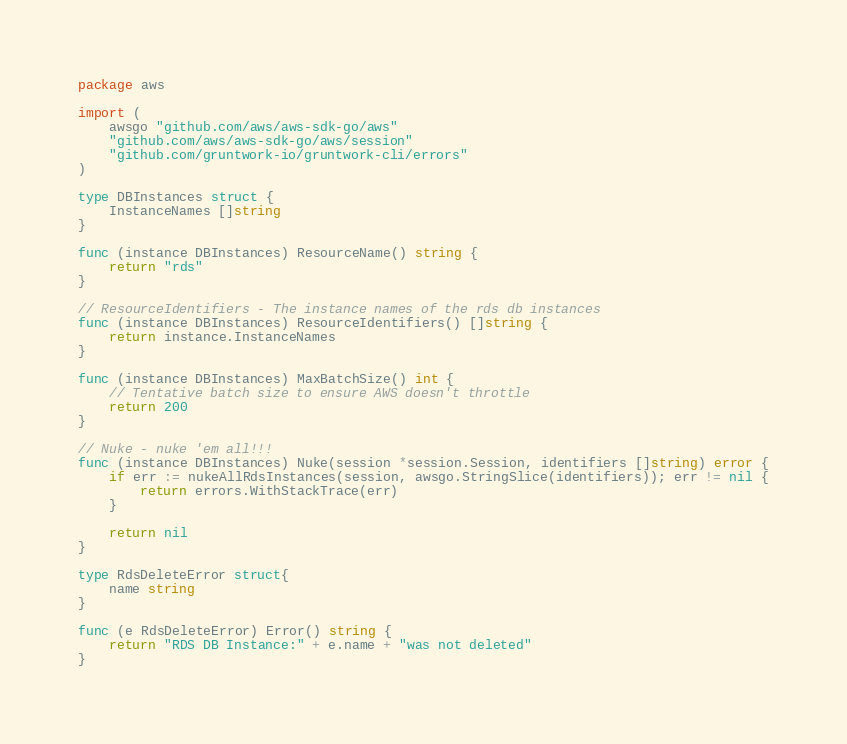<code> <loc_0><loc_0><loc_500><loc_500><_Go_>package aws

import (
	awsgo "github.com/aws/aws-sdk-go/aws"
	"github.com/aws/aws-sdk-go/aws/session"
	"github.com/gruntwork-io/gruntwork-cli/errors"
)

type DBInstances struct {
	InstanceNames []string
}

func (instance DBInstances) ResourceName() string {
	return "rds"
}

// ResourceIdentifiers - The instance names of the rds db instances
func (instance DBInstances) ResourceIdentifiers() []string {
	return instance.InstanceNames
}

func (instance DBInstances) MaxBatchSize() int {
	// Tentative batch size to ensure AWS doesn't throttle
	return 200
}

// Nuke - nuke 'em all!!!
func (instance DBInstances) Nuke(session *session.Session, identifiers []string) error {
	if err := nukeAllRdsInstances(session, awsgo.StringSlice(identifiers)); err != nil {
		return errors.WithStackTrace(err)
	}

	return nil
}

type RdsDeleteError struct{
	name string
}

func (e RdsDeleteError) Error() string {
	return "RDS DB Instance:" + e.name + "was not deleted"
}
</code> 